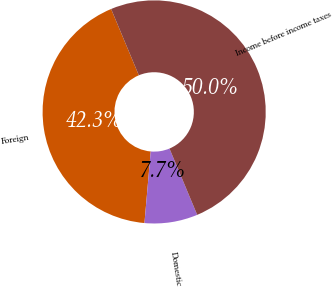Convert chart to OTSL. <chart><loc_0><loc_0><loc_500><loc_500><pie_chart><fcel>Foreign<fcel>Domestic<fcel>Income before income taxes<nl><fcel>42.31%<fcel>7.69%<fcel>50.0%<nl></chart> 